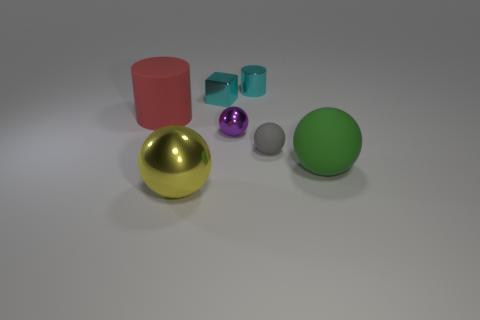Add 3 big cyan shiny cylinders. How many objects exist? 10 Subtract all spheres. How many objects are left? 3 Add 5 small cyan metal objects. How many small cyan metal objects exist? 7 Subtract 0 green cylinders. How many objects are left? 7 Subtract all purple matte balls. Subtract all big cylinders. How many objects are left? 6 Add 5 tiny metal cylinders. How many tiny metal cylinders are left? 6 